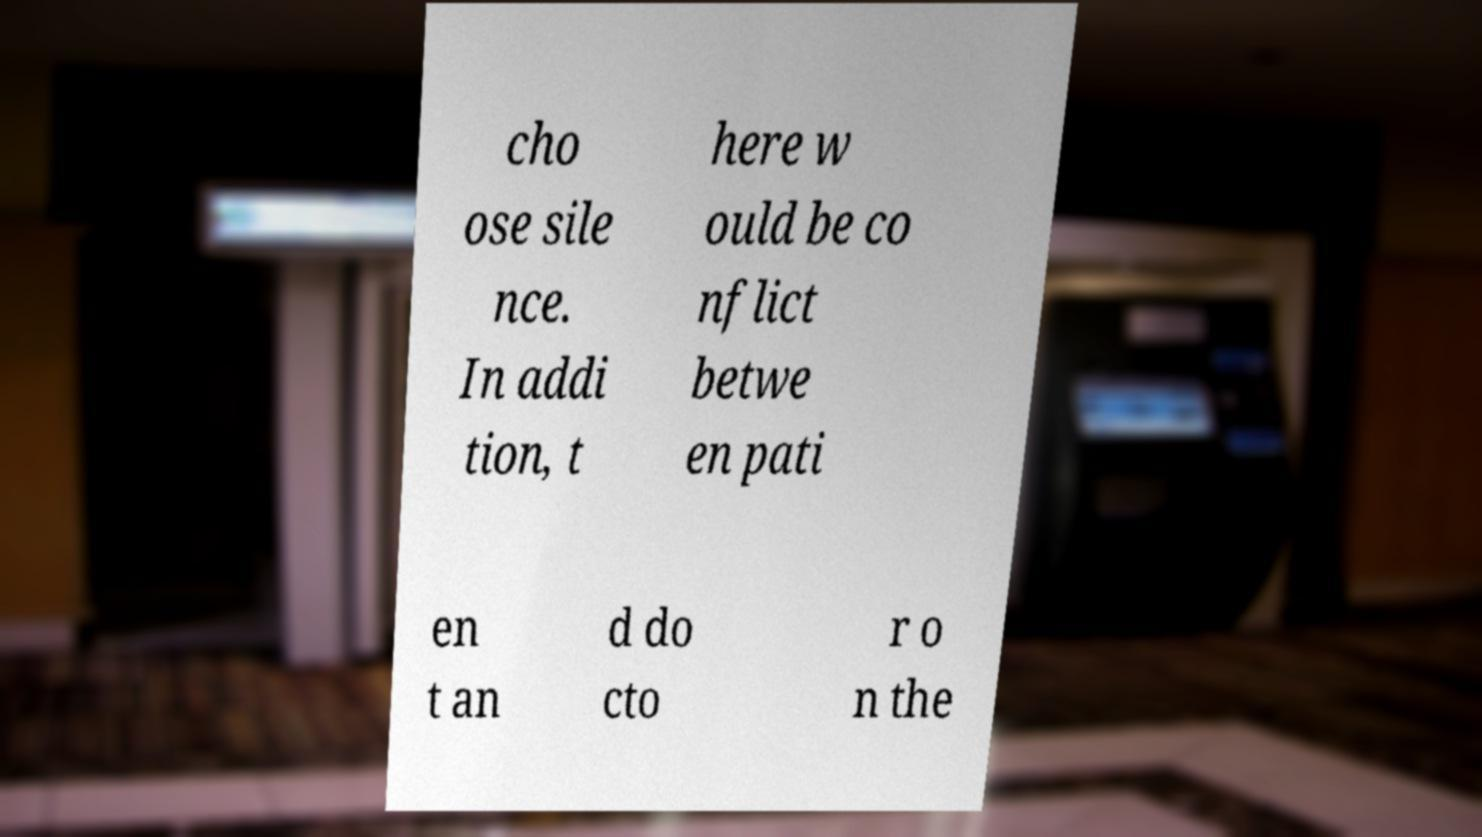For documentation purposes, I need the text within this image transcribed. Could you provide that? cho ose sile nce. In addi tion, t here w ould be co nflict betwe en pati en t an d do cto r o n the 